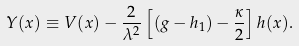Convert formula to latex. <formula><loc_0><loc_0><loc_500><loc_500>Y ( x ) \equiv V ( x ) - \frac { 2 } { \lambda ^ { 2 } } \left [ ( g - h _ { 1 } ) - \frac { \kappa } { 2 } \right ] h ( x ) .</formula> 